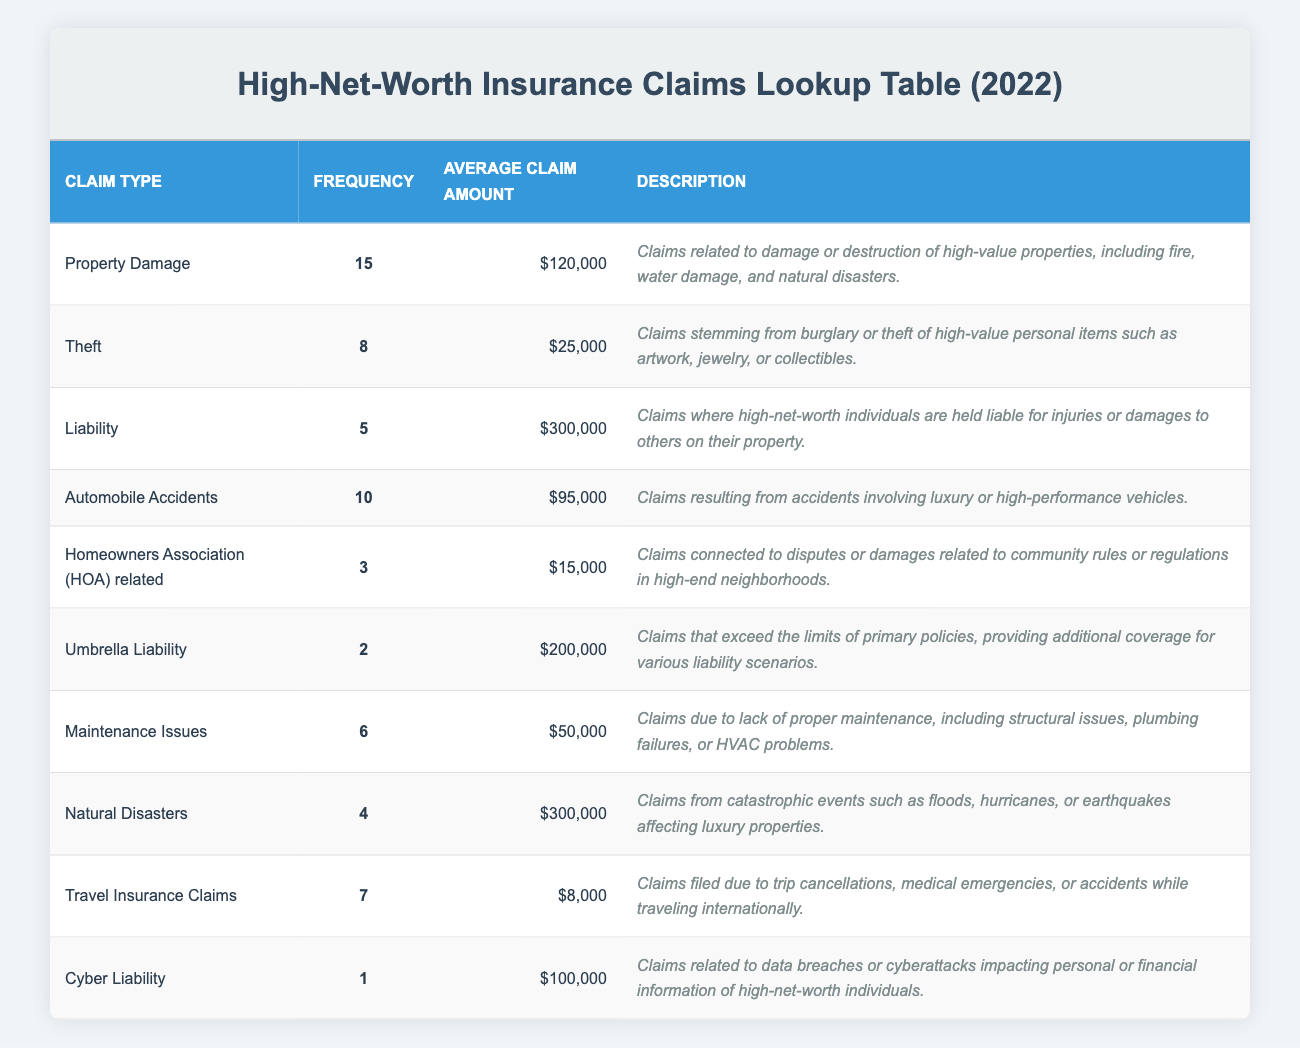What is the claim type with the highest frequency? The claim type with the highest frequency is located in the "Frequency" column. By scanning the rows, we see that "Property Damage" has a frequency of 15, which is higher than any other claim type listed.
Answer: Property Damage How many claims were related to Theft? The number of claims related to Theft can be found in the row for "Theft" within the "Frequency" column. The value noted there is 8.
Answer: 8 What is the average claim amount for Liability claims? The average claim amount for Liability is directly taken from the "Average Claim Amount" column for the "Liability" row, which states $300,000.
Answer: $300,000 What is the total frequency of claims related to Homeowners Association (HOA) and Maintenance Issues combined? To find the total frequency for both claim types, we refer to their respective frequency values: HOA related claims have a frequency of 3 and Maintenance Issues have a frequency of 6. Adding these together gives 3 + 6 = 9.
Answer: 9 Is the average claim amount for Natural Disasters greater than $200,000? We check the average claim amount for Natural Disasters, which is listed as $300,000. Since $300,000 is indeed greater than $200,000, the answer is yes.
Answer: Yes How many claim types have an average claim amount exceeding $100,000? We need to evaluate the "Average Claim Amount" for each claim type: Property Damage ($120,000), Liability ($300,000), Automobile Accidents ($95,000), Umbrella Liability ($200,000), and Natural Disasters ($300,000). The claim types above $100,000 are Property Damage, Liability, Umbrella Liability, and Natural Disasters, making a total of 4 claim types.
Answer: 4 What is the total average claim amount for all the claim types listed? To find the total average claim amount, we first need to sum the average amounts listed: $120,000 + $25,000 + $300,000 + $95,000 + $15,000 + $200,000 + $50,000 + $300,000 + $8,000 + $100,000. This totals $1,213,000. Then, to find the total average, we divide by the number of claim types (10): $1,213,000 / 10 = $121,300.
Answer: $121,300 Is there more frequency of Automobile Accidents than Theft? Looking at the "Frequency" values, Automobile Accidents have a frequency of 10, while Theft has a frequency of 8. Since 10 is greater than 8, the answer is yes.
Answer: Yes What is the average claim amount of the claims with the lowest frequency? We need to find which claim type has the lowest frequency, which is “Cyber Liability” at a frequency of 1. We then check its average claim amount in the "Average Claim Amount" column, which is $100,000. This is the only claim with the lowest frequency.
Answer: $100,000 